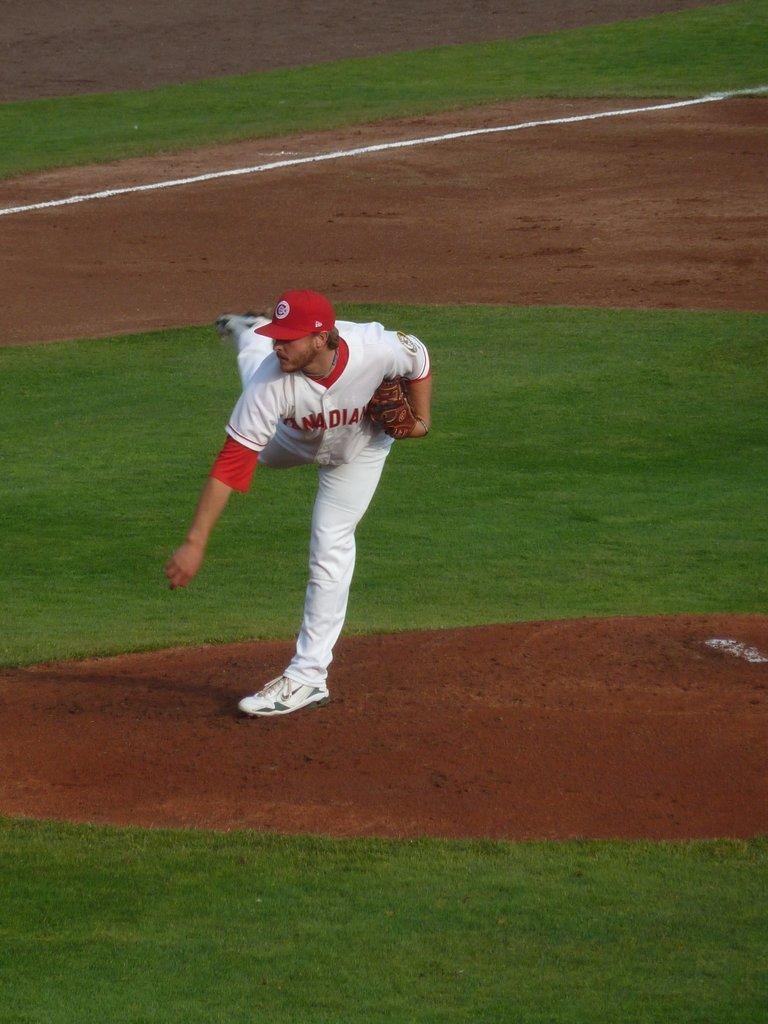<image>
Render a clear and concise summary of the photo. The Canadian pitcher has just delivered a pitch from the mound. 